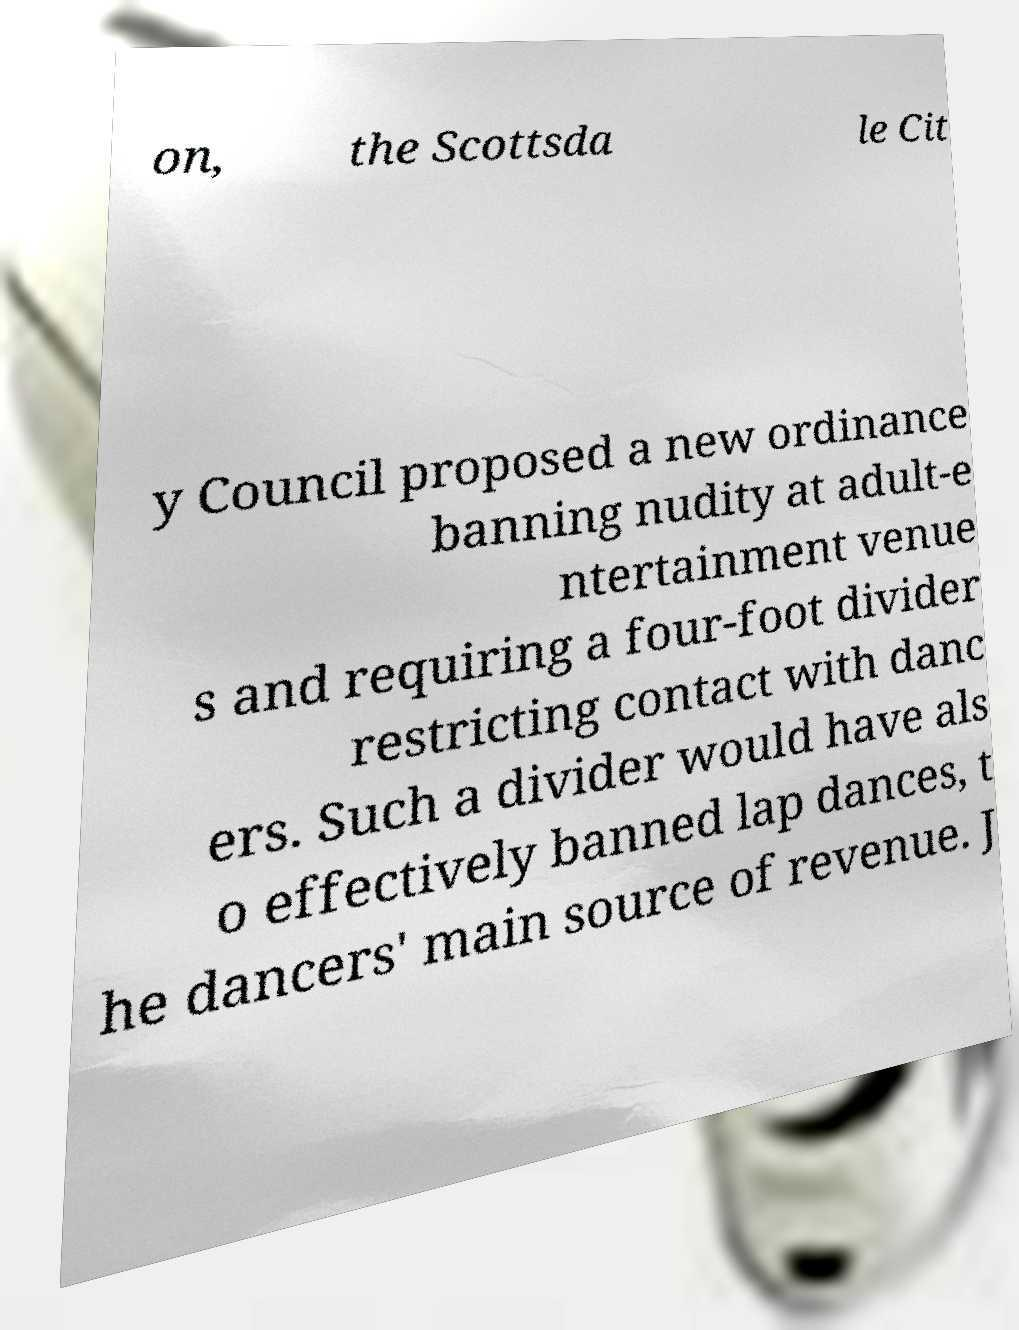For documentation purposes, I need the text within this image transcribed. Could you provide that? on, the Scottsda le Cit y Council proposed a new ordinance banning nudity at adult-e ntertainment venue s and requiring a four-foot divider restricting contact with danc ers. Such a divider would have als o effectively banned lap dances, t he dancers' main source of revenue. J 